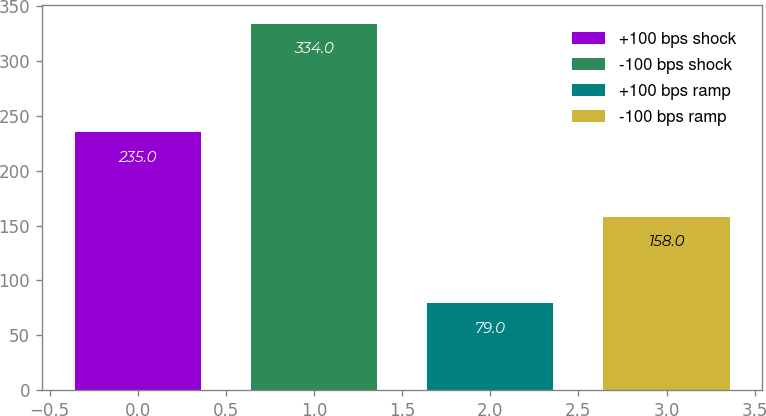Convert chart to OTSL. <chart><loc_0><loc_0><loc_500><loc_500><bar_chart><fcel>+100 bps shock<fcel>-100 bps shock<fcel>+100 bps ramp<fcel>-100 bps ramp<nl><fcel>235<fcel>334<fcel>79<fcel>158<nl></chart> 